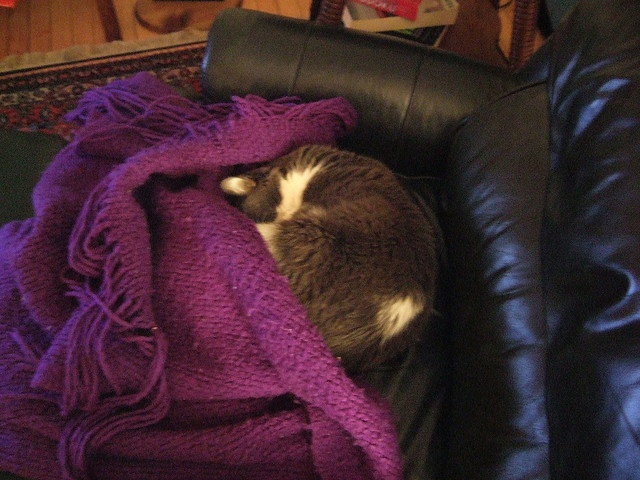Describe the objects in this image and their specific colors. I can see couch in black, brown, and purple tones and cat in brown, black, maroon, and khaki tones in this image. 